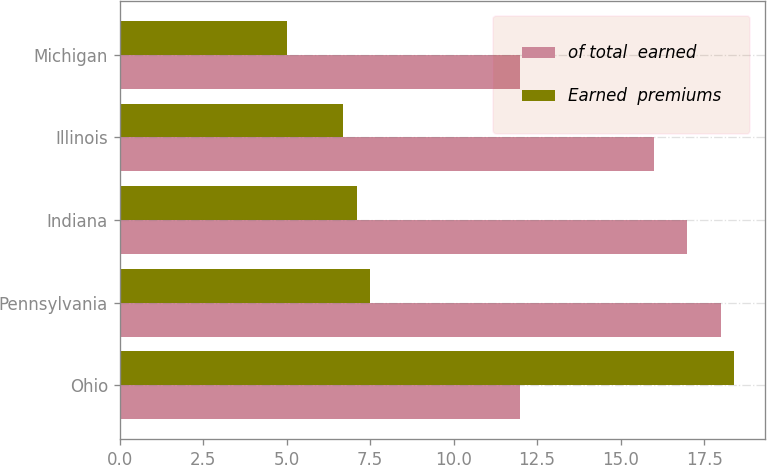<chart> <loc_0><loc_0><loc_500><loc_500><stacked_bar_chart><ecel><fcel>Ohio<fcel>Pennsylvania<fcel>Indiana<fcel>Illinois<fcel>Michigan<nl><fcel>of total  earned<fcel>12<fcel>18<fcel>17<fcel>16<fcel>12<nl><fcel>Earned  premiums<fcel>18.4<fcel>7.5<fcel>7.1<fcel>6.7<fcel>5<nl></chart> 